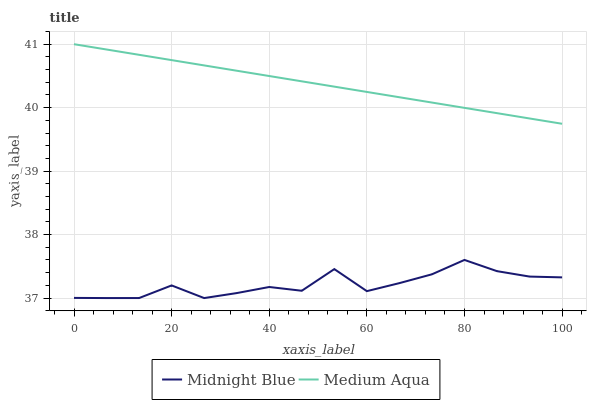Does Midnight Blue have the minimum area under the curve?
Answer yes or no. Yes. Does Medium Aqua have the maximum area under the curve?
Answer yes or no. Yes. Does Midnight Blue have the maximum area under the curve?
Answer yes or no. No. Is Medium Aqua the smoothest?
Answer yes or no. Yes. Is Midnight Blue the roughest?
Answer yes or no. Yes. Is Midnight Blue the smoothest?
Answer yes or no. No. Does Midnight Blue have the lowest value?
Answer yes or no. Yes. Does Medium Aqua have the highest value?
Answer yes or no. Yes. Does Midnight Blue have the highest value?
Answer yes or no. No. Is Midnight Blue less than Medium Aqua?
Answer yes or no. Yes. Is Medium Aqua greater than Midnight Blue?
Answer yes or no. Yes. Does Midnight Blue intersect Medium Aqua?
Answer yes or no. No. 